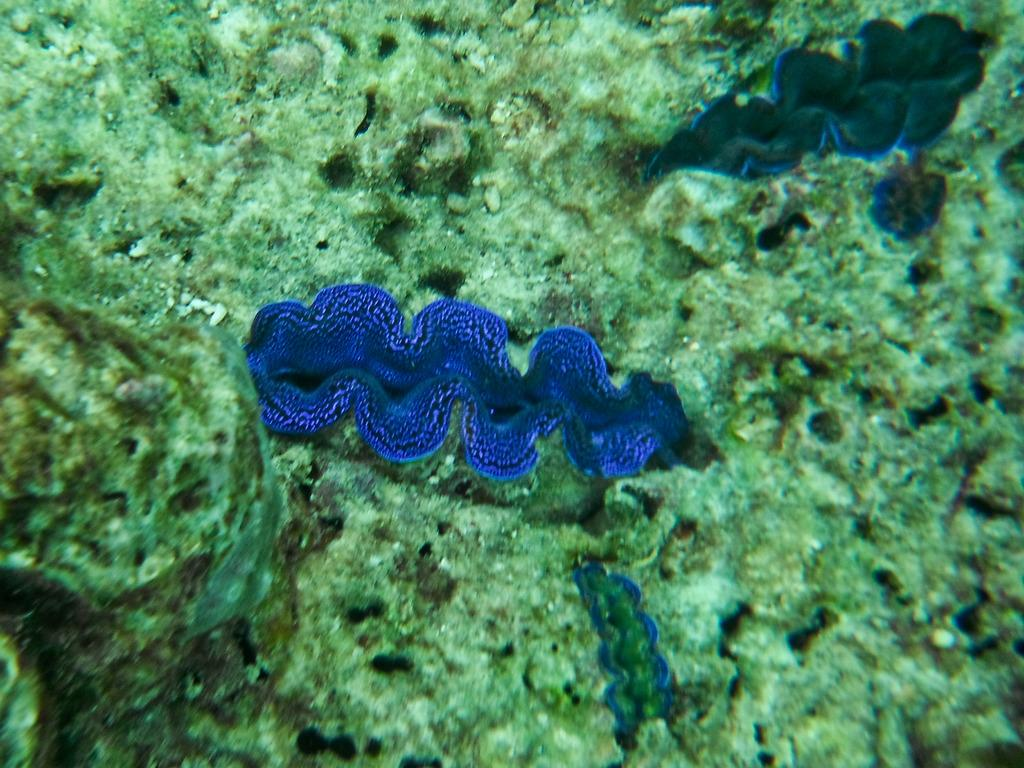What type of environment is shown in the image? The image depicts an underwater environment. Can you describe any specific features of the underwater environment? Unfortunately, the provided facts do not include any specific features of the underwater environment. Are there any living organisms visible in the image? The provided facts do not mention any living organisms in the image. What is the value of the zinc found in the trees in the image? There are no trees or zinc present in the image, as it depicts an underwater environment. 